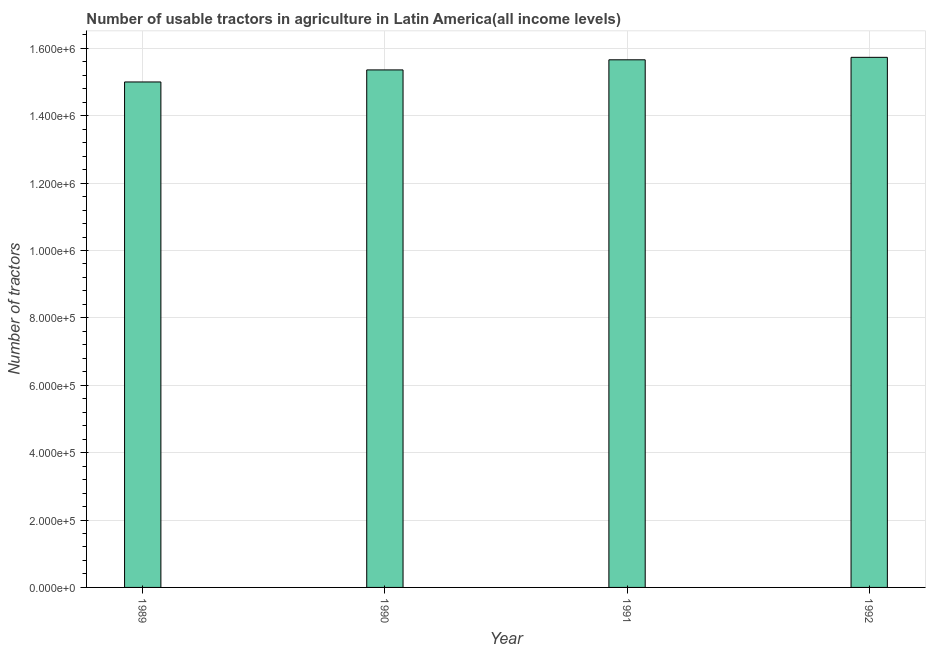Does the graph contain grids?
Offer a terse response. Yes. What is the title of the graph?
Your response must be concise. Number of usable tractors in agriculture in Latin America(all income levels). What is the label or title of the X-axis?
Your answer should be very brief. Year. What is the label or title of the Y-axis?
Keep it short and to the point. Number of tractors. What is the number of tractors in 1991?
Provide a short and direct response. 1.57e+06. Across all years, what is the maximum number of tractors?
Provide a succinct answer. 1.57e+06. Across all years, what is the minimum number of tractors?
Your answer should be compact. 1.50e+06. In which year was the number of tractors maximum?
Ensure brevity in your answer.  1992. In which year was the number of tractors minimum?
Your response must be concise. 1989. What is the sum of the number of tractors?
Make the answer very short. 6.18e+06. What is the difference between the number of tractors in 1989 and 1992?
Give a very brief answer. -7.31e+04. What is the average number of tractors per year?
Provide a succinct answer. 1.54e+06. What is the median number of tractors?
Make the answer very short. 1.55e+06. Is the number of tractors in 1989 less than that in 1992?
Make the answer very short. Yes. Is the difference between the number of tractors in 1990 and 1992 greater than the difference between any two years?
Keep it short and to the point. No. What is the difference between the highest and the second highest number of tractors?
Your answer should be compact. 7362. What is the difference between the highest and the lowest number of tractors?
Offer a terse response. 7.31e+04. How many years are there in the graph?
Keep it short and to the point. 4. What is the difference between two consecutive major ticks on the Y-axis?
Offer a terse response. 2.00e+05. What is the Number of tractors in 1989?
Provide a short and direct response. 1.50e+06. What is the Number of tractors in 1990?
Make the answer very short. 1.54e+06. What is the Number of tractors of 1991?
Your response must be concise. 1.57e+06. What is the Number of tractors in 1992?
Offer a very short reply. 1.57e+06. What is the difference between the Number of tractors in 1989 and 1990?
Provide a short and direct response. -3.58e+04. What is the difference between the Number of tractors in 1989 and 1991?
Keep it short and to the point. -6.58e+04. What is the difference between the Number of tractors in 1989 and 1992?
Your answer should be compact. -7.31e+04. What is the difference between the Number of tractors in 1990 and 1991?
Keep it short and to the point. -3.00e+04. What is the difference between the Number of tractors in 1990 and 1992?
Provide a short and direct response. -3.73e+04. What is the difference between the Number of tractors in 1991 and 1992?
Offer a terse response. -7362. What is the ratio of the Number of tractors in 1989 to that in 1990?
Offer a terse response. 0.98. What is the ratio of the Number of tractors in 1989 to that in 1991?
Provide a short and direct response. 0.96. What is the ratio of the Number of tractors in 1989 to that in 1992?
Your response must be concise. 0.95. What is the ratio of the Number of tractors in 1990 to that in 1991?
Make the answer very short. 0.98. What is the ratio of the Number of tractors in 1991 to that in 1992?
Keep it short and to the point. 0.99. 